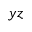Convert formula to latex. <formula><loc_0><loc_0><loc_500><loc_500>y z</formula> 